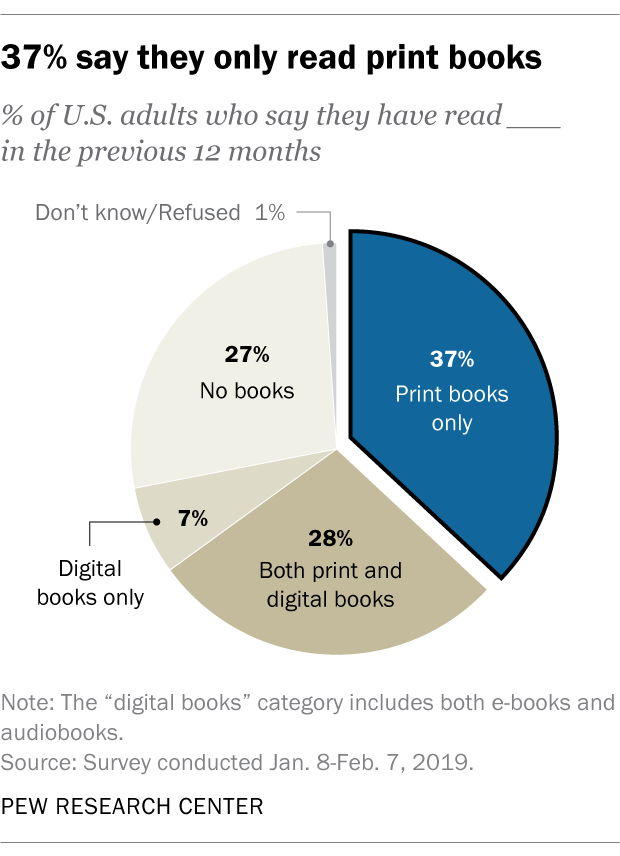Specify some key components in this picture. The ratio between the length of the blue and gray segments is approximately 1.542361111... The median value among all pies is 27. 